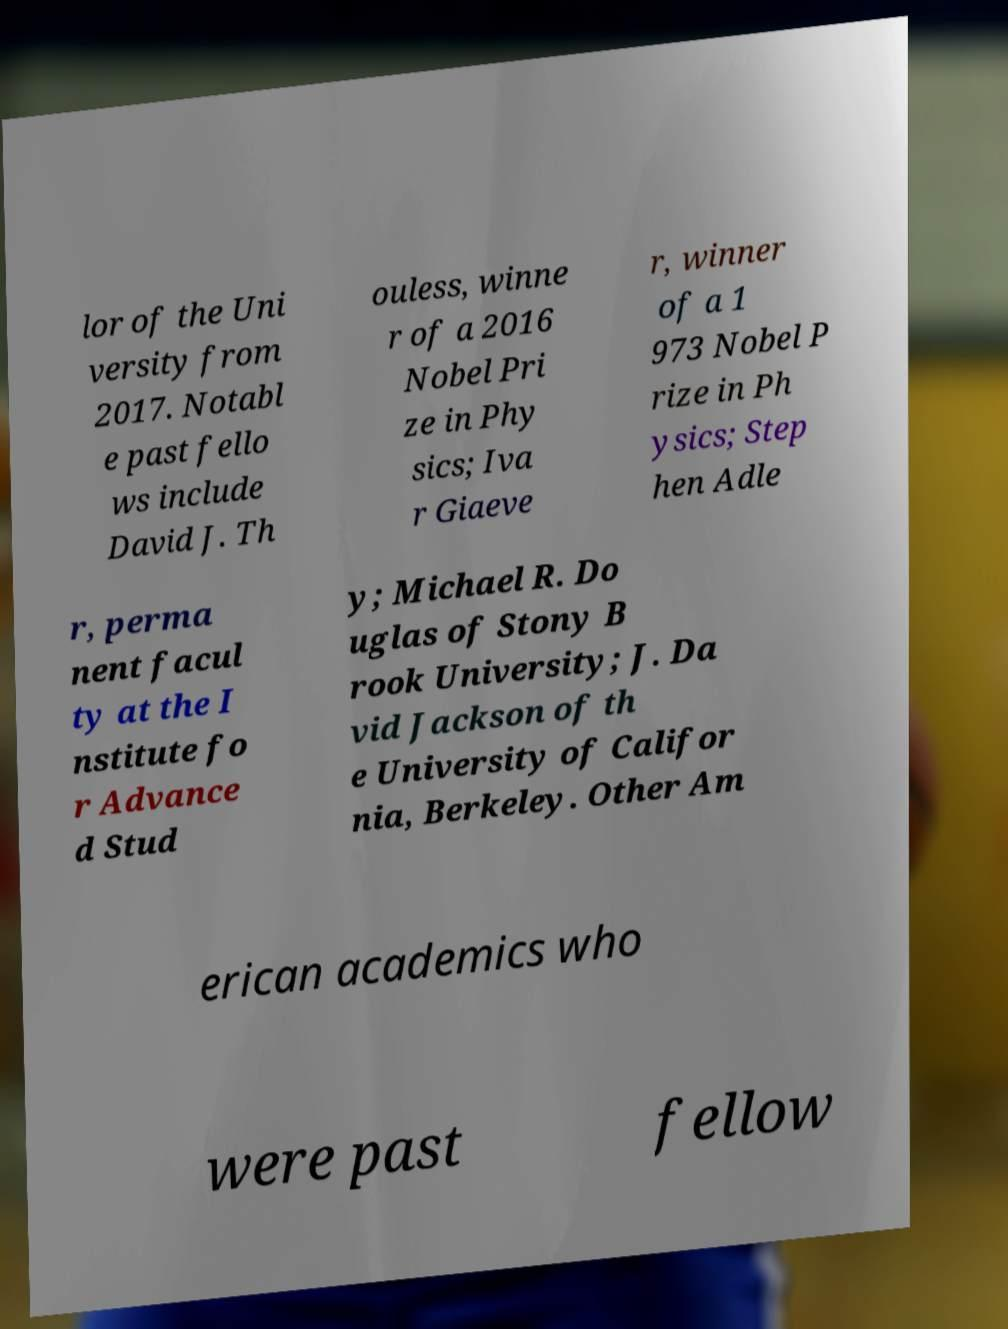Can you read and provide the text displayed in the image?This photo seems to have some interesting text. Can you extract and type it out for me? lor of the Uni versity from 2017. Notabl e past fello ws include David J. Th ouless, winne r of a 2016 Nobel Pri ze in Phy sics; Iva r Giaeve r, winner of a 1 973 Nobel P rize in Ph ysics; Step hen Adle r, perma nent facul ty at the I nstitute fo r Advance d Stud y; Michael R. Do uglas of Stony B rook University; J. Da vid Jackson of th e University of Califor nia, Berkeley. Other Am erican academics who were past fellow 